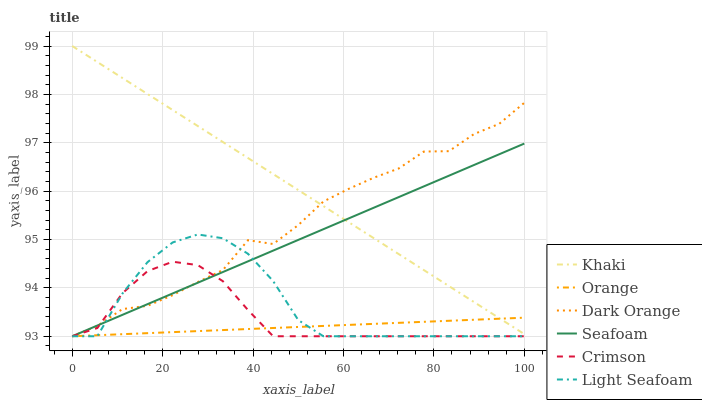Does Seafoam have the minimum area under the curve?
Answer yes or no. No. Does Seafoam have the maximum area under the curve?
Answer yes or no. No. Is Seafoam the smoothest?
Answer yes or no. No. Is Seafoam the roughest?
Answer yes or no. No. Does Khaki have the lowest value?
Answer yes or no. No. Does Seafoam have the highest value?
Answer yes or no. No. Is Light Seafoam less than Khaki?
Answer yes or no. Yes. Is Khaki greater than Light Seafoam?
Answer yes or no. Yes. Does Light Seafoam intersect Khaki?
Answer yes or no. No. 